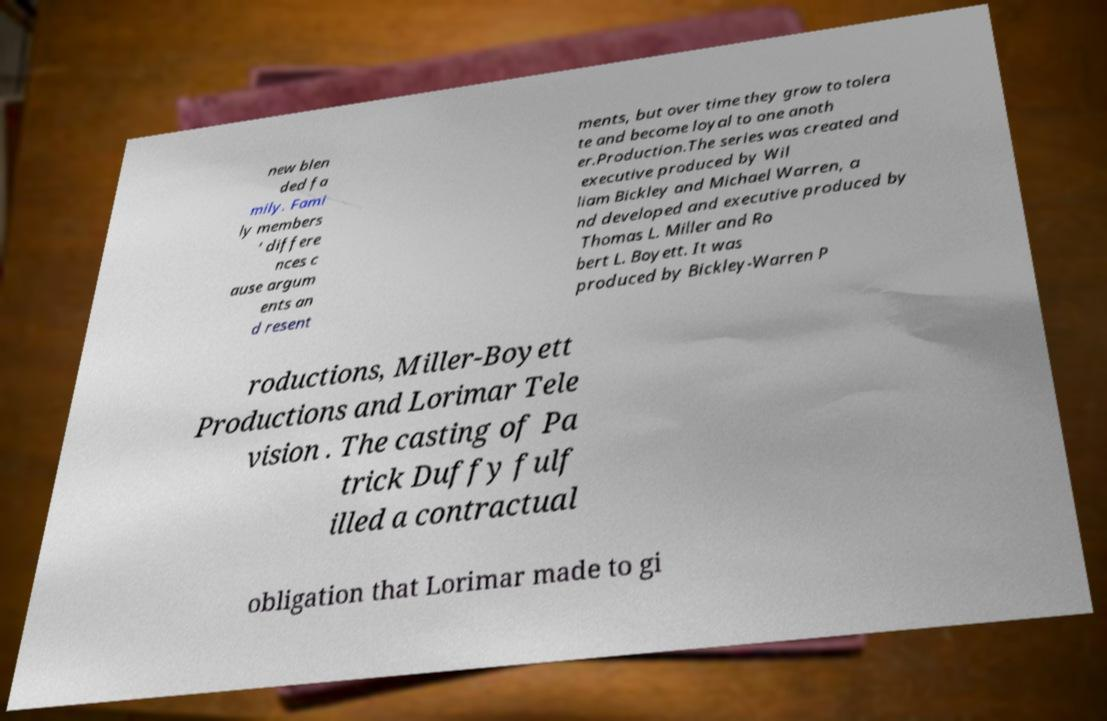Can you read and provide the text displayed in the image?This photo seems to have some interesting text. Can you extract and type it out for me? new blen ded fa mily. Fami ly members ’ differe nces c ause argum ents an d resent ments, but over time they grow to tolera te and become loyal to one anoth er.Production.The series was created and executive produced by Wil liam Bickley and Michael Warren, a nd developed and executive produced by Thomas L. Miller and Ro bert L. Boyett. It was produced by Bickley-Warren P roductions, Miller-Boyett Productions and Lorimar Tele vision . The casting of Pa trick Duffy fulf illed a contractual obligation that Lorimar made to gi 